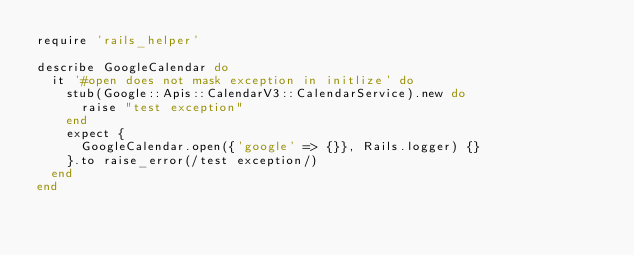Convert code to text. <code><loc_0><loc_0><loc_500><loc_500><_Ruby_>require 'rails_helper'

describe GoogleCalendar do
  it '#open does not mask exception in initlize' do
    stub(Google::Apis::CalendarV3::CalendarService).new do
      raise "test exception"
    end
    expect {
      GoogleCalendar.open({'google' => {}}, Rails.logger) {}
    }.to raise_error(/test exception/)
  end
end
</code> 